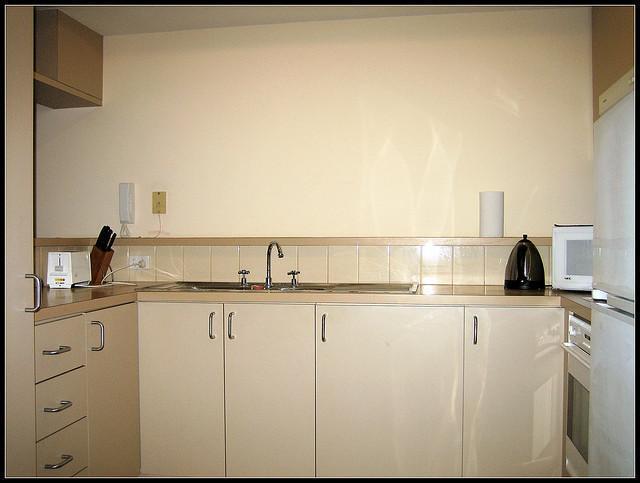How many cats?
Give a very brief answer. 0. How many cars have a surfboard on the roof?
Give a very brief answer. 0. 